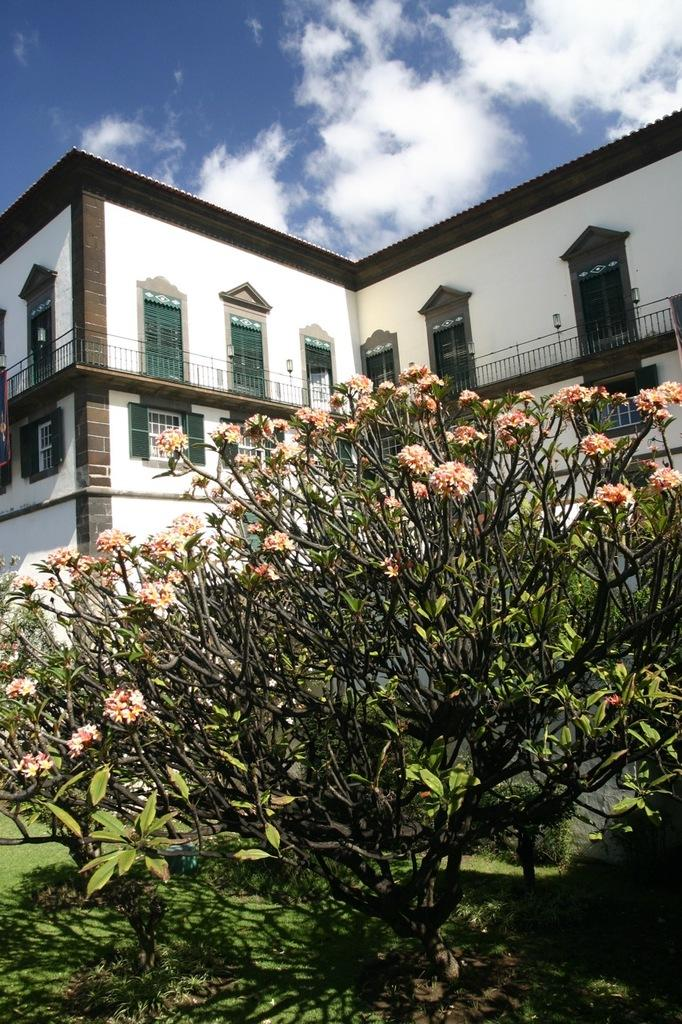What type of plant is present in the image? There are flowers on a plant in the image. What can be seen in the background of the image? There is a building visible behind the plant in the image. How many letters does the grandmother hold in the image? There is no grandmother or letters present in the image. 